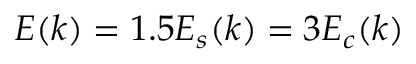<formula> <loc_0><loc_0><loc_500><loc_500>E ( k ) = 1 . 5 { { E } _ { s } } ( k ) = 3 { { E } _ { c } } ( k )</formula> 